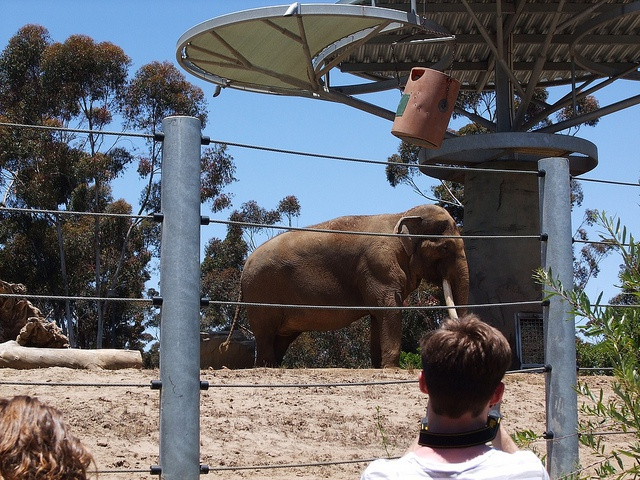Describe the objects in this image and their specific colors. I can see elephant in lightblue, black, maroon, and gray tones, people in lightblue, black, white, maroon, and brown tones, and people in lightblue, maroon, black, gray, and tan tones in this image. 